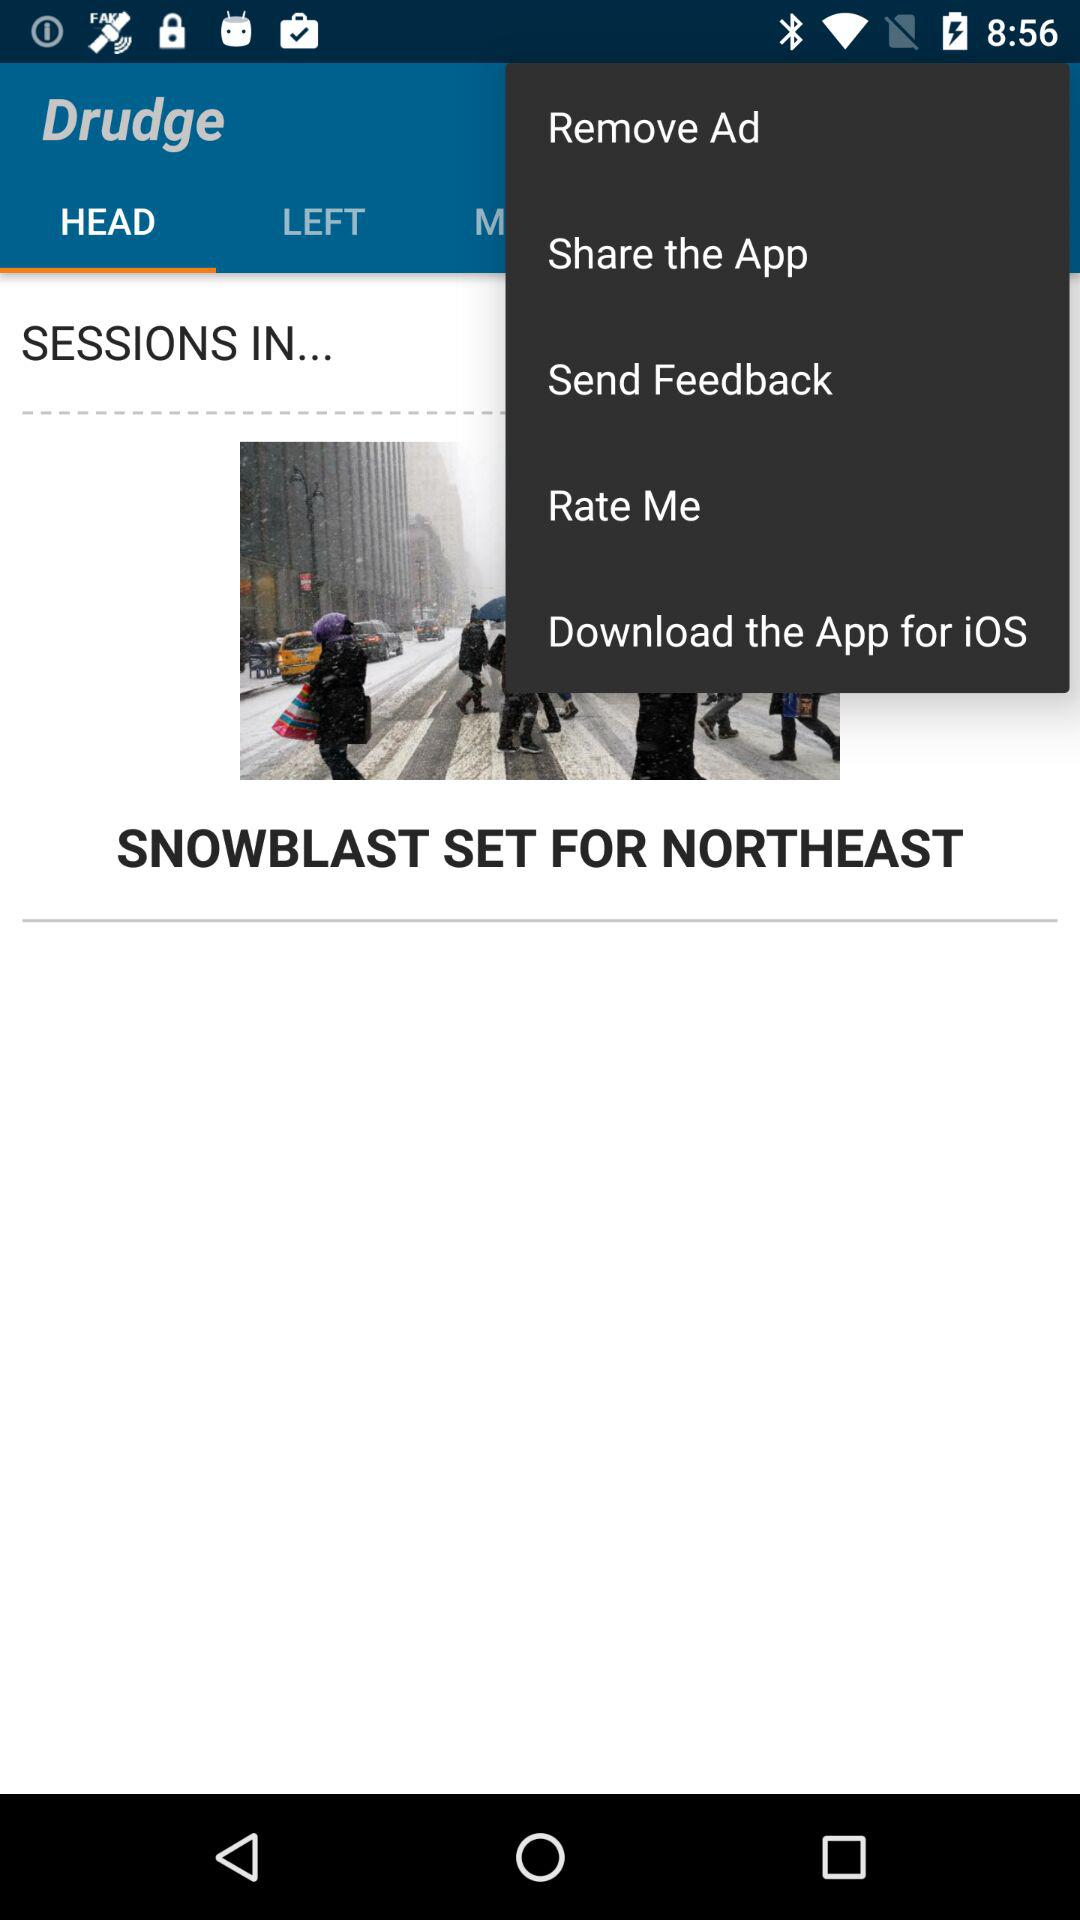Which option is selected in the drop-down menu?
When the provided information is insufficient, respond with <no answer>. <no answer> 